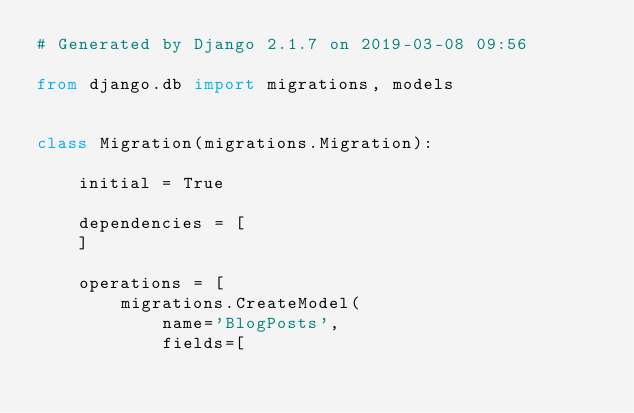<code> <loc_0><loc_0><loc_500><loc_500><_Python_># Generated by Django 2.1.7 on 2019-03-08 09:56

from django.db import migrations, models


class Migration(migrations.Migration):

    initial = True

    dependencies = [
    ]

    operations = [
        migrations.CreateModel(
            name='BlogPosts',
            fields=[</code> 